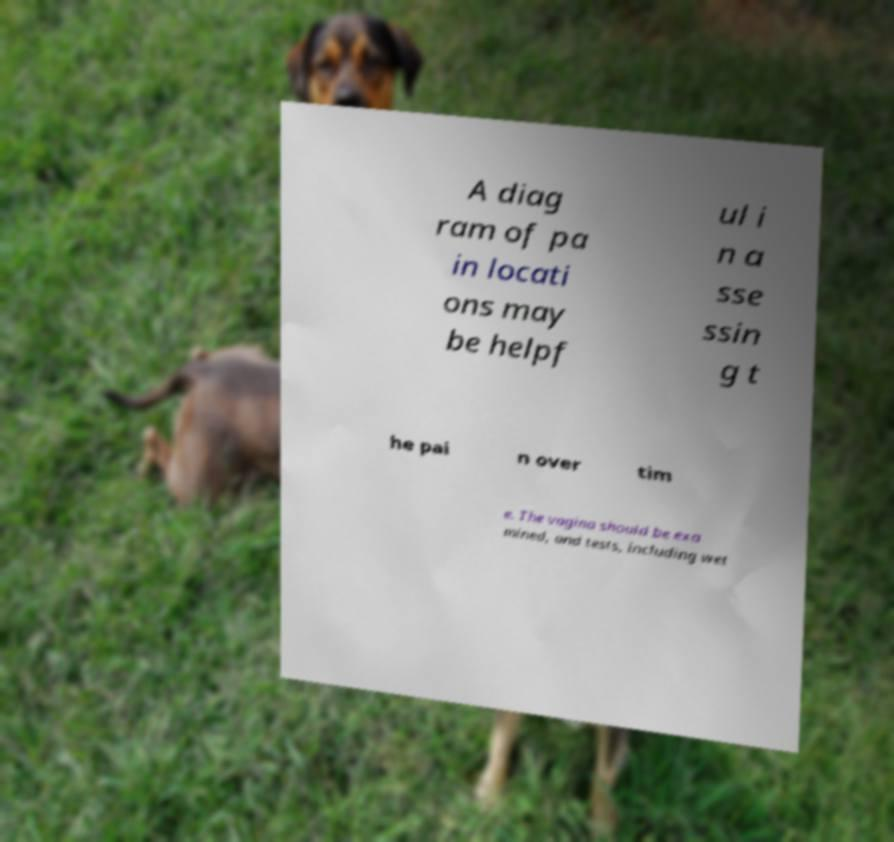There's text embedded in this image that I need extracted. Can you transcribe it verbatim? A diag ram of pa in locati ons may be helpf ul i n a sse ssin g t he pai n over tim e. The vagina should be exa mined, and tests, including wet 